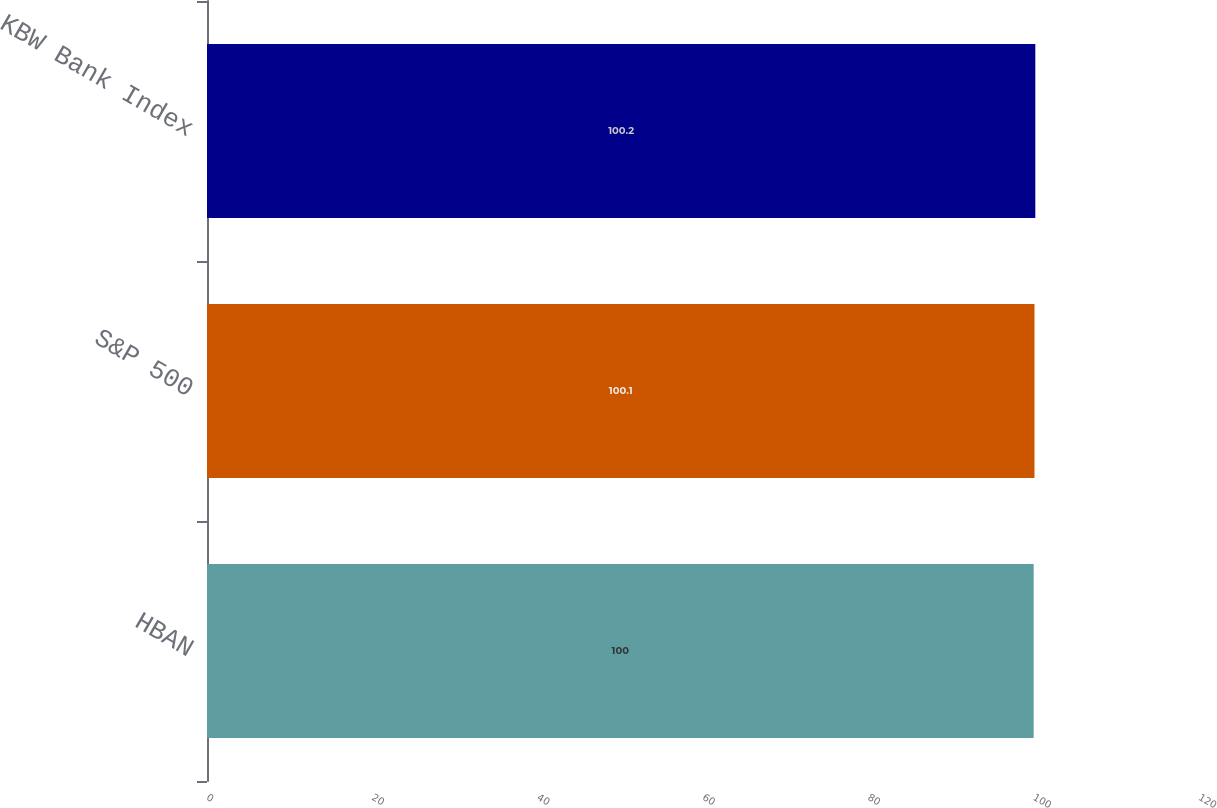<chart> <loc_0><loc_0><loc_500><loc_500><bar_chart><fcel>HBAN<fcel>S&P 500<fcel>KBW Bank Index<nl><fcel>100<fcel>100.1<fcel>100.2<nl></chart> 